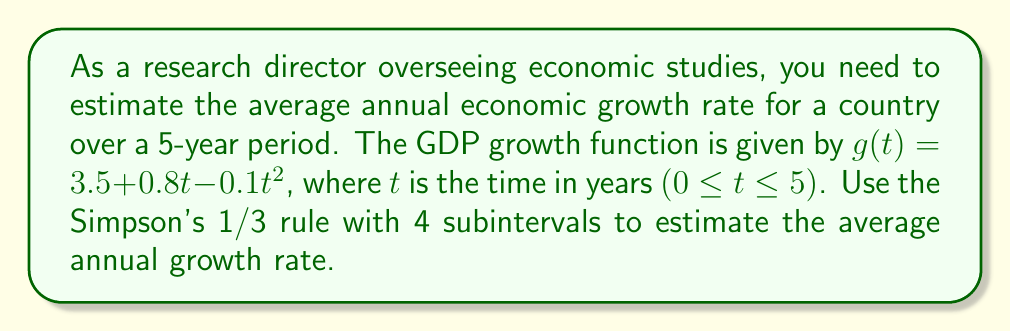Provide a solution to this math problem. 1) The average growth rate over the period is given by:
   $$\text{Average Growth Rate} = \frac{1}{5} \int_0^5 g(t) dt$$

2) Simpson's 1/3 rule with n=4 subintervals is:
   $$\int_a^b f(x) dx \approx \frac{h}{3}[f(x_0) + 4f(x_1) + 2f(x_2) + 4f(x_3) + f(x_4)]$$
   where $h = \frac{b-a}{n}$ and $x_i = a + ih$

3) In our case, $a=0$, $b=5$, $n=4$, so $h = \frac{5-0}{4} = 1.25$

4) Calculate function values:
   $g(0) = 3.5 + 0.8(0) - 0.1(0)^2 = 3.5$
   $g(1.25) = 3.5 + 0.8(1.25) - 0.1(1.25)^2 = 4.34375$
   $g(2.5) = 3.5 + 0.8(2.5) - 0.1(2.5)^2 = 4.375$
   $g(3.75) = 3.5 + 0.8(3.75) - 0.1(3.75)^2 = 3.59375$
   $g(5) = 3.5 + 0.8(5) - 0.1(5)^2 = 2$

5) Apply Simpson's 1/3 rule:
   $$\int_0^5 g(t) dt \approx \frac{1.25}{3}[3.5 + 4(4.34375) + 2(4.375) + 4(3.59375) + 2]$$
   $$= \frac{1.25}{3}[3.5 + 17.375 + 8.75 + 14.375 + 2] = \frac{1.25}{3}(46) = 19.1667$$

6) Calculate the average growth rate:
   $$\text{Average Growth Rate} = \frac{1}{5} \cdot 19.1667 = 3.8333$$
Answer: 3.8333% 